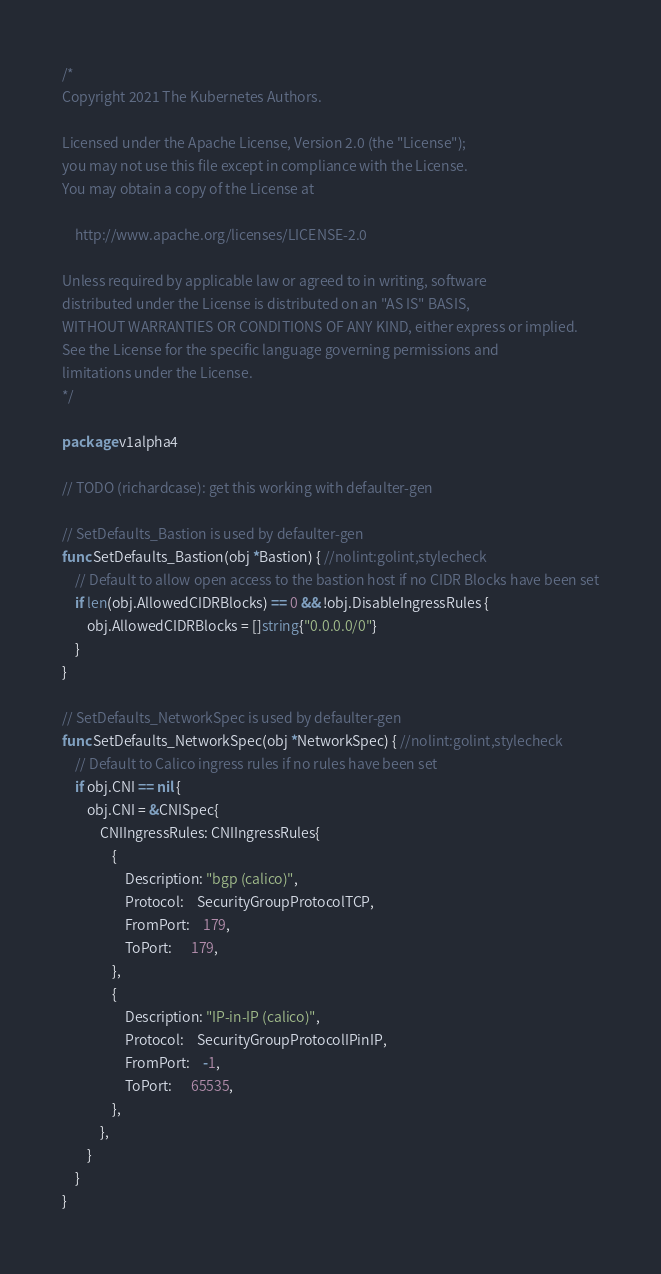Convert code to text. <code><loc_0><loc_0><loc_500><loc_500><_Go_>/*
Copyright 2021 The Kubernetes Authors.

Licensed under the Apache License, Version 2.0 (the "License");
you may not use this file except in compliance with the License.
You may obtain a copy of the License at

    http://www.apache.org/licenses/LICENSE-2.0

Unless required by applicable law or agreed to in writing, software
distributed under the License is distributed on an "AS IS" BASIS,
WITHOUT WARRANTIES OR CONDITIONS OF ANY KIND, either express or implied.
See the License for the specific language governing permissions and
limitations under the License.
*/

package v1alpha4

// TODO (richardcase): get this working with defaulter-gen

// SetDefaults_Bastion is used by defaulter-gen
func SetDefaults_Bastion(obj *Bastion) { //nolint:golint,stylecheck
	// Default to allow open access to the bastion host if no CIDR Blocks have been set
	if len(obj.AllowedCIDRBlocks) == 0 && !obj.DisableIngressRules {
		obj.AllowedCIDRBlocks = []string{"0.0.0.0/0"}
	}
}

// SetDefaults_NetworkSpec is used by defaulter-gen
func SetDefaults_NetworkSpec(obj *NetworkSpec) { //nolint:golint,stylecheck
	// Default to Calico ingress rules if no rules have been set
	if obj.CNI == nil {
		obj.CNI = &CNISpec{
			CNIIngressRules: CNIIngressRules{
				{
					Description: "bgp (calico)",
					Protocol:    SecurityGroupProtocolTCP,
					FromPort:    179,
					ToPort:      179,
				},
				{
					Description: "IP-in-IP (calico)",
					Protocol:    SecurityGroupProtocolIPinIP,
					FromPort:    -1,
					ToPort:      65535,
				},
			},
		}
	}
}
</code> 